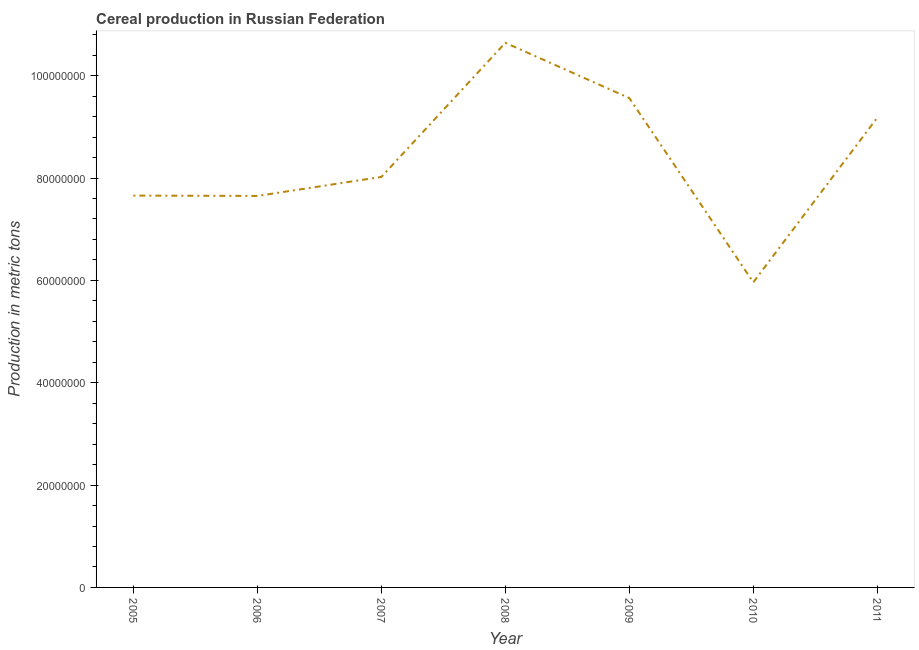What is the cereal production in 2008?
Keep it short and to the point. 1.06e+08. Across all years, what is the maximum cereal production?
Your answer should be very brief. 1.06e+08. Across all years, what is the minimum cereal production?
Offer a very short reply. 5.96e+07. What is the sum of the cereal production?
Give a very brief answer. 5.87e+08. What is the difference between the cereal production in 2005 and 2010?
Offer a terse response. 1.69e+07. What is the average cereal production per year?
Give a very brief answer. 8.38e+07. What is the median cereal production?
Offer a very short reply. 8.02e+07. What is the ratio of the cereal production in 2006 to that in 2010?
Ensure brevity in your answer.  1.28. Is the cereal production in 2010 less than that in 2011?
Ensure brevity in your answer.  Yes. What is the difference between the highest and the second highest cereal production?
Ensure brevity in your answer.  1.08e+07. What is the difference between the highest and the lowest cereal production?
Provide a succinct answer. 4.68e+07. In how many years, is the cereal production greater than the average cereal production taken over all years?
Offer a terse response. 3. Does the cereal production monotonically increase over the years?
Provide a succinct answer. No. How many lines are there?
Make the answer very short. 1. What is the difference between two consecutive major ticks on the Y-axis?
Provide a short and direct response. 2.00e+07. Are the values on the major ticks of Y-axis written in scientific E-notation?
Offer a terse response. No. Does the graph contain any zero values?
Provide a succinct answer. No. Does the graph contain grids?
Your answer should be compact. No. What is the title of the graph?
Keep it short and to the point. Cereal production in Russian Federation. What is the label or title of the X-axis?
Keep it short and to the point. Year. What is the label or title of the Y-axis?
Provide a short and direct response. Production in metric tons. What is the Production in metric tons in 2005?
Make the answer very short. 7.66e+07. What is the Production in metric tons of 2006?
Make the answer very short. 7.65e+07. What is the Production in metric tons of 2007?
Provide a short and direct response. 8.02e+07. What is the Production in metric tons in 2008?
Offer a terse response. 1.06e+08. What is the Production in metric tons in 2009?
Your answer should be very brief. 9.56e+07. What is the Production in metric tons of 2010?
Ensure brevity in your answer.  5.96e+07. What is the Production in metric tons of 2011?
Offer a terse response. 9.18e+07. What is the difference between the Production in metric tons in 2005 and 2006?
Ensure brevity in your answer.  6.90e+04. What is the difference between the Production in metric tons in 2005 and 2007?
Offer a terse response. -3.64e+06. What is the difference between the Production in metric tons in 2005 and 2008?
Keep it short and to the point. -2.99e+07. What is the difference between the Production in metric tons in 2005 and 2009?
Offer a very short reply. -1.91e+07. What is the difference between the Production in metric tons in 2005 and 2010?
Provide a short and direct response. 1.69e+07. What is the difference between the Production in metric tons in 2005 and 2011?
Ensure brevity in your answer.  -1.52e+07. What is the difference between the Production in metric tons in 2006 and 2007?
Make the answer very short. -3.71e+06. What is the difference between the Production in metric tons in 2006 and 2008?
Give a very brief answer. -2.99e+07. What is the difference between the Production in metric tons in 2006 and 2009?
Make the answer very short. -1.91e+07. What is the difference between the Production in metric tons in 2006 and 2010?
Your answer should be compact. 1.69e+07. What is the difference between the Production in metric tons in 2006 and 2011?
Your answer should be compact. -1.53e+07. What is the difference between the Production in metric tons in 2007 and 2008?
Your answer should be compact. -2.62e+07. What is the difference between the Production in metric tons in 2007 and 2009?
Ensure brevity in your answer.  -1.54e+07. What is the difference between the Production in metric tons in 2007 and 2010?
Make the answer very short. 2.06e+07. What is the difference between the Production in metric tons in 2007 and 2011?
Make the answer very short. -1.16e+07. What is the difference between the Production in metric tons in 2008 and 2009?
Your response must be concise. 1.08e+07. What is the difference between the Production in metric tons in 2008 and 2010?
Ensure brevity in your answer.  4.68e+07. What is the difference between the Production in metric tons in 2008 and 2011?
Your answer should be compact. 1.46e+07. What is the difference between the Production in metric tons in 2009 and 2010?
Make the answer very short. 3.60e+07. What is the difference between the Production in metric tons in 2009 and 2011?
Ensure brevity in your answer.  3.82e+06. What is the difference between the Production in metric tons in 2010 and 2011?
Your answer should be very brief. -3.22e+07. What is the ratio of the Production in metric tons in 2005 to that in 2006?
Provide a short and direct response. 1. What is the ratio of the Production in metric tons in 2005 to that in 2007?
Offer a very short reply. 0.95. What is the ratio of the Production in metric tons in 2005 to that in 2008?
Your answer should be compact. 0.72. What is the ratio of the Production in metric tons in 2005 to that in 2009?
Provide a short and direct response. 0.8. What is the ratio of the Production in metric tons in 2005 to that in 2010?
Provide a short and direct response. 1.28. What is the ratio of the Production in metric tons in 2005 to that in 2011?
Provide a succinct answer. 0.83. What is the ratio of the Production in metric tons in 2006 to that in 2007?
Offer a terse response. 0.95. What is the ratio of the Production in metric tons in 2006 to that in 2008?
Keep it short and to the point. 0.72. What is the ratio of the Production in metric tons in 2006 to that in 2010?
Your answer should be compact. 1.28. What is the ratio of the Production in metric tons in 2006 to that in 2011?
Your answer should be very brief. 0.83. What is the ratio of the Production in metric tons in 2007 to that in 2008?
Offer a terse response. 0.75. What is the ratio of the Production in metric tons in 2007 to that in 2009?
Your answer should be compact. 0.84. What is the ratio of the Production in metric tons in 2007 to that in 2010?
Your answer should be compact. 1.34. What is the ratio of the Production in metric tons in 2007 to that in 2011?
Give a very brief answer. 0.87. What is the ratio of the Production in metric tons in 2008 to that in 2009?
Provide a succinct answer. 1.11. What is the ratio of the Production in metric tons in 2008 to that in 2010?
Offer a terse response. 1.78. What is the ratio of the Production in metric tons in 2008 to that in 2011?
Provide a succinct answer. 1.16. What is the ratio of the Production in metric tons in 2009 to that in 2010?
Provide a short and direct response. 1.6. What is the ratio of the Production in metric tons in 2009 to that in 2011?
Make the answer very short. 1.04. What is the ratio of the Production in metric tons in 2010 to that in 2011?
Offer a terse response. 0.65. 